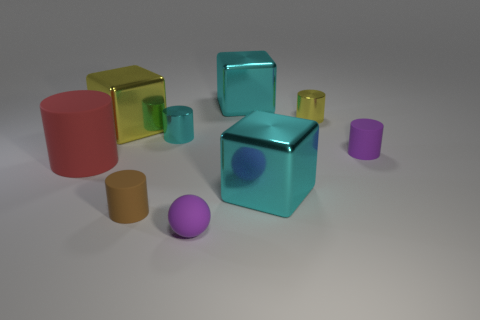Subtract all purple matte cylinders. How many cylinders are left? 4 Add 1 big cyan blocks. How many objects exist? 10 Subtract all brown cylinders. How many cylinders are left? 4 Subtract 1 cubes. How many cubes are left? 2 Subtract all spheres. How many objects are left? 8 Subtract all purple cylinders. Subtract all purple balls. How many cylinders are left? 4 Subtract all purple cylinders. How many yellow blocks are left? 1 Subtract all small brown objects. Subtract all tiny yellow shiny cylinders. How many objects are left? 7 Add 1 big cyan cubes. How many big cyan cubes are left? 3 Add 3 red matte cylinders. How many red matte cylinders exist? 4 